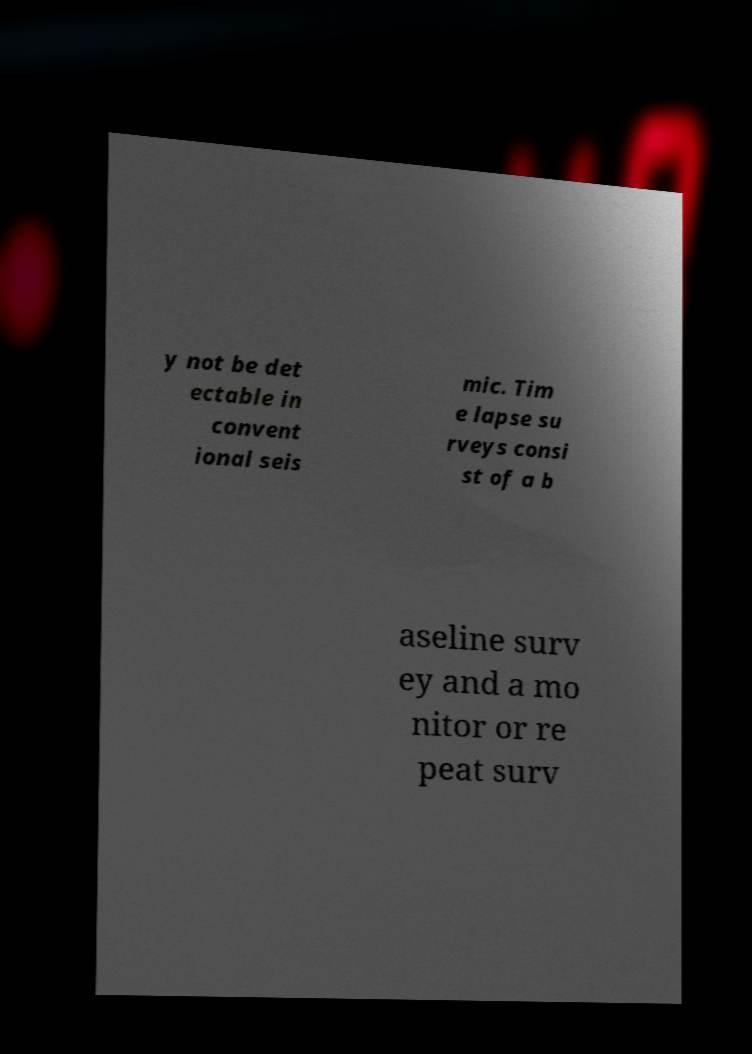Can you read and provide the text displayed in the image?This photo seems to have some interesting text. Can you extract and type it out for me? y not be det ectable in convent ional seis mic. Tim e lapse su rveys consi st of a b aseline surv ey and a mo nitor or re peat surv 